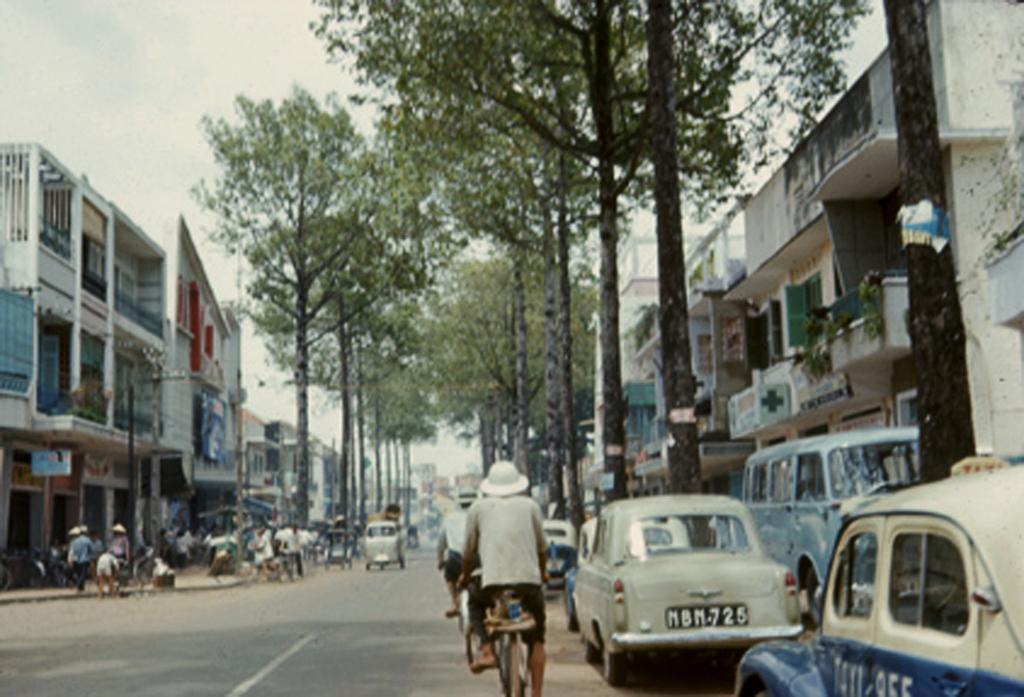How would you summarize this image in a sentence or two? There is a group of people. Some persons are riding on a bicycle. Some persons are walking. We can see in background tree,buildings and sky. 